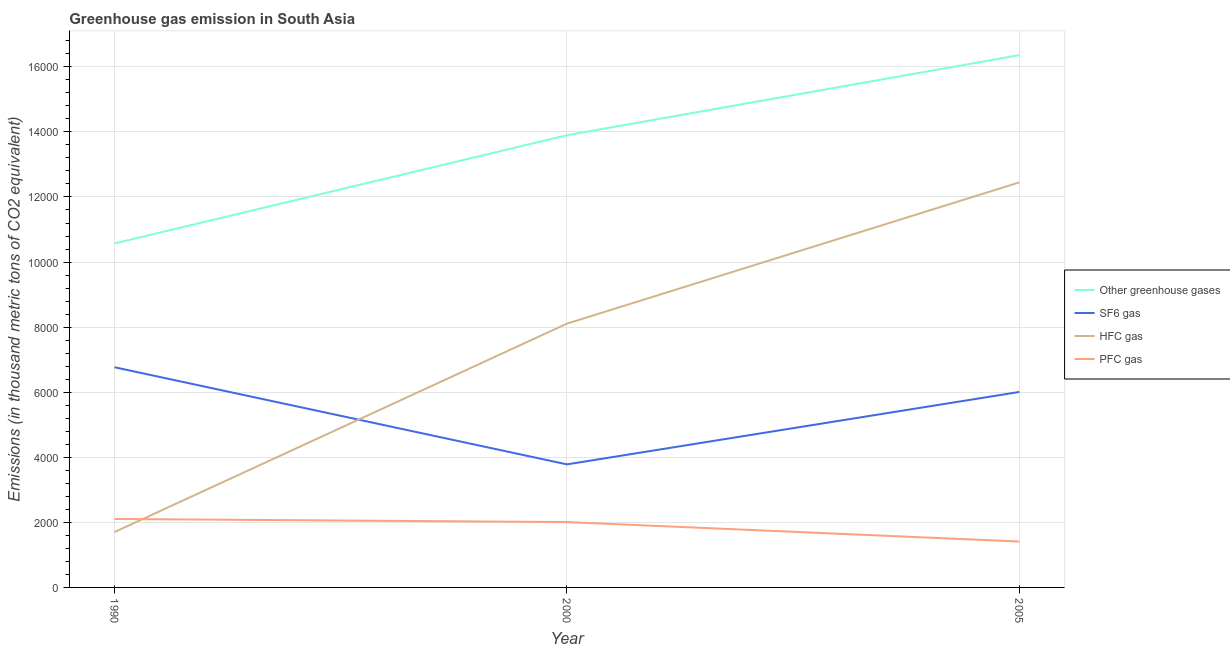How many different coloured lines are there?
Provide a succinct answer. 4. Is the number of lines equal to the number of legend labels?
Provide a succinct answer. Yes. What is the emission of hfc gas in 2005?
Give a very brief answer. 1.24e+04. Across all years, what is the maximum emission of hfc gas?
Offer a very short reply. 1.24e+04. Across all years, what is the minimum emission of hfc gas?
Your answer should be very brief. 1702.1. In which year was the emission of hfc gas minimum?
Make the answer very short. 1990. What is the total emission of greenhouse gases in the graph?
Give a very brief answer. 4.08e+04. What is the difference between the emission of pfc gas in 1990 and that in 2005?
Your answer should be very brief. 693.16. What is the difference between the emission of sf6 gas in 2000 and the emission of greenhouse gases in 2005?
Give a very brief answer. -1.26e+04. What is the average emission of sf6 gas per year?
Your answer should be compact. 5518.65. In the year 2005, what is the difference between the emission of greenhouse gases and emission of hfc gas?
Keep it short and to the point. 3910.64. In how many years, is the emission of sf6 gas greater than 5600 thousand metric tons?
Keep it short and to the point. 2. What is the ratio of the emission of hfc gas in 1990 to that in 2005?
Your answer should be very brief. 0.14. Is the difference between the emission of pfc gas in 2000 and 2005 greater than the difference between the emission of sf6 gas in 2000 and 2005?
Your response must be concise. Yes. What is the difference between the highest and the second highest emission of hfc gas?
Provide a succinct answer. 4341.26. What is the difference between the highest and the lowest emission of greenhouse gases?
Ensure brevity in your answer.  5786.5. In how many years, is the emission of hfc gas greater than the average emission of hfc gas taken over all years?
Your answer should be compact. 2. Is it the case that in every year, the sum of the emission of hfc gas and emission of sf6 gas is greater than the sum of emission of greenhouse gases and emission of pfc gas?
Your answer should be compact. No. Is it the case that in every year, the sum of the emission of greenhouse gases and emission of sf6 gas is greater than the emission of hfc gas?
Your answer should be very brief. Yes. Is the emission of hfc gas strictly greater than the emission of pfc gas over the years?
Make the answer very short. No. How many lines are there?
Keep it short and to the point. 4. Are the values on the major ticks of Y-axis written in scientific E-notation?
Give a very brief answer. No. Does the graph contain any zero values?
Make the answer very short. No. Does the graph contain grids?
Your answer should be compact. Yes. What is the title of the graph?
Make the answer very short. Greenhouse gas emission in South Asia. What is the label or title of the Y-axis?
Offer a very short reply. Emissions (in thousand metric tons of CO2 equivalent). What is the Emissions (in thousand metric tons of CO2 equivalent) in Other greenhouse gases in 1990?
Provide a succinct answer. 1.06e+04. What is the Emissions (in thousand metric tons of CO2 equivalent) of SF6 gas in 1990?
Your answer should be very brief. 6766.5. What is the Emissions (in thousand metric tons of CO2 equivalent) in HFC gas in 1990?
Your answer should be compact. 1702.1. What is the Emissions (in thousand metric tons of CO2 equivalent) in PFC gas in 1990?
Make the answer very short. 2104. What is the Emissions (in thousand metric tons of CO2 equivalent) in Other greenhouse gases in 2000?
Provide a short and direct response. 1.39e+04. What is the Emissions (in thousand metric tons of CO2 equivalent) in SF6 gas in 2000?
Give a very brief answer. 3781.9. What is the Emissions (in thousand metric tons of CO2 equivalent) in HFC gas in 2000?
Make the answer very short. 8107.2. What is the Emissions (in thousand metric tons of CO2 equivalent) of PFC gas in 2000?
Offer a very short reply. 2008.8. What is the Emissions (in thousand metric tons of CO2 equivalent) of Other greenhouse gases in 2005?
Keep it short and to the point. 1.64e+04. What is the Emissions (in thousand metric tons of CO2 equivalent) in SF6 gas in 2005?
Provide a succinct answer. 6007.56. What is the Emissions (in thousand metric tons of CO2 equivalent) in HFC gas in 2005?
Make the answer very short. 1.24e+04. What is the Emissions (in thousand metric tons of CO2 equivalent) of PFC gas in 2005?
Keep it short and to the point. 1410.84. Across all years, what is the maximum Emissions (in thousand metric tons of CO2 equivalent) in Other greenhouse gases?
Give a very brief answer. 1.64e+04. Across all years, what is the maximum Emissions (in thousand metric tons of CO2 equivalent) of SF6 gas?
Provide a succinct answer. 6766.5. Across all years, what is the maximum Emissions (in thousand metric tons of CO2 equivalent) of HFC gas?
Offer a terse response. 1.24e+04. Across all years, what is the maximum Emissions (in thousand metric tons of CO2 equivalent) of PFC gas?
Offer a terse response. 2104. Across all years, what is the minimum Emissions (in thousand metric tons of CO2 equivalent) in Other greenhouse gases?
Give a very brief answer. 1.06e+04. Across all years, what is the minimum Emissions (in thousand metric tons of CO2 equivalent) of SF6 gas?
Your answer should be very brief. 3781.9. Across all years, what is the minimum Emissions (in thousand metric tons of CO2 equivalent) of HFC gas?
Provide a succinct answer. 1702.1. Across all years, what is the minimum Emissions (in thousand metric tons of CO2 equivalent) in PFC gas?
Your answer should be very brief. 1410.84. What is the total Emissions (in thousand metric tons of CO2 equivalent) in Other greenhouse gases in the graph?
Give a very brief answer. 4.08e+04. What is the total Emissions (in thousand metric tons of CO2 equivalent) in SF6 gas in the graph?
Ensure brevity in your answer.  1.66e+04. What is the total Emissions (in thousand metric tons of CO2 equivalent) in HFC gas in the graph?
Provide a succinct answer. 2.23e+04. What is the total Emissions (in thousand metric tons of CO2 equivalent) of PFC gas in the graph?
Offer a very short reply. 5523.64. What is the difference between the Emissions (in thousand metric tons of CO2 equivalent) of Other greenhouse gases in 1990 and that in 2000?
Provide a short and direct response. -3325.3. What is the difference between the Emissions (in thousand metric tons of CO2 equivalent) in SF6 gas in 1990 and that in 2000?
Keep it short and to the point. 2984.6. What is the difference between the Emissions (in thousand metric tons of CO2 equivalent) of HFC gas in 1990 and that in 2000?
Your response must be concise. -6405.1. What is the difference between the Emissions (in thousand metric tons of CO2 equivalent) in PFC gas in 1990 and that in 2000?
Your answer should be very brief. 95.2. What is the difference between the Emissions (in thousand metric tons of CO2 equivalent) in Other greenhouse gases in 1990 and that in 2005?
Provide a succinct answer. -5786.5. What is the difference between the Emissions (in thousand metric tons of CO2 equivalent) in SF6 gas in 1990 and that in 2005?
Provide a short and direct response. 758.94. What is the difference between the Emissions (in thousand metric tons of CO2 equivalent) of HFC gas in 1990 and that in 2005?
Your response must be concise. -1.07e+04. What is the difference between the Emissions (in thousand metric tons of CO2 equivalent) of PFC gas in 1990 and that in 2005?
Give a very brief answer. 693.16. What is the difference between the Emissions (in thousand metric tons of CO2 equivalent) of Other greenhouse gases in 2000 and that in 2005?
Provide a succinct answer. -2461.2. What is the difference between the Emissions (in thousand metric tons of CO2 equivalent) of SF6 gas in 2000 and that in 2005?
Provide a short and direct response. -2225.66. What is the difference between the Emissions (in thousand metric tons of CO2 equivalent) in HFC gas in 2000 and that in 2005?
Give a very brief answer. -4341.26. What is the difference between the Emissions (in thousand metric tons of CO2 equivalent) in PFC gas in 2000 and that in 2005?
Your response must be concise. 597.96. What is the difference between the Emissions (in thousand metric tons of CO2 equivalent) in Other greenhouse gases in 1990 and the Emissions (in thousand metric tons of CO2 equivalent) in SF6 gas in 2000?
Keep it short and to the point. 6790.7. What is the difference between the Emissions (in thousand metric tons of CO2 equivalent) of Other greenhouse gases in 1990 and the Emissions (in thousand metric tons of CO2 equivalent) of HFC gas in 2000?
Provide a short and direct response. 2465.4. What is the difference between the Emissions (in thousand metric tons of CO2 equivalent) of Other greenhouse gases in 1990 and the Emissions (in thousand metric tons of CO2 equivalent) of PFC gas in 2000?
Your answer should be compact. 8563.8. What is the difference between the Emissions (in thousand metric tons of CO2 equivalent) of SF6 gas in 1990 and the Emissions (in thousand metric tons of CO2 equivalent) of HFC gas in 2000?
Provide a short and direct response. -1340.7. What is the difference between the Emissions (in thousand metric tons of CO2 equivalent) in SF6 gas in 1990 and the Emissions (in thousand metric tons of CO2 equivalent) in PFC gas in 2000?
Provide a short and direct response. 4757.7. What is the difference between the Emissions (in thousand metric tons of CO2 equivalent) of HFC gas in 1990 and the Emissions (in thousand metric tons of CO2 equivalent) of PFC gas in 2000?
Your answer should be very brief. -306.7. What is the difference between the Emissions (in thousand metric tons of CO2 equivalent) in Other greenhouse gases in 1990 and the Emissions (in thousand metric tons of CO2 equivalent) in SF6 gas in 2005?
Offer a very short reply. 4565.04. What is the difference between the Emissions (in thousand metric tons of CO2 equivalent) in Other greenhouse gases in 1990 and the Emissions (in thousand metric tons of CO2 equivalent) in HFC gas in 2005?
Ensure brevity in your answer.  -1875.86. What is the difference between the Emissions (in thousand metric tons of CO2 equivalent) of Other greenhouse gases in 1990 and the Emissions (in thousand metric tons of CO2 equivalent) of PFC gas in 2005?
Ensure brevity in your answer.  9161.76. What is the difference between the Emissions (in thousand metric tons of CO2 equivalent) in SF6 gas in 1990 and the Emissions (in thousand metric tons of CO2 equivalent) in HFC gas in 2005?
Keep it short and to the point. -5681.96. What is the difference between the Emissions (in thousand metric tons of CO2 equivalent) of SF6 gas in 1990 and the Emissions (in thousand metric tons of CO2 equivalent) of PFC gas in 2005?
Give a very brief answer. 5355.66. What is the difference between the Emissions (in thousand metric tons of CO2 equivalent) of HFC gas in 1990 and the Emissions (in thousand metric tons of CO2 equivalent) of PFC gas in 2005?
Provide a short and direct response. 291.26. What is the difference between the Emissions (in thousand metric tons of CO2 equivalent) of Other greenhouse gases in 2000 and the Emissions (in thousand metric tons of CO2 equivalent) of SF6 gas in 2005?
Provide a succinct answer. 7890.34. What is the difference between the Emissions (in thousand metric tons of CO2 equivalent) in Other greenhouse gases in 2000 and the Emissions (in thousand metric tons of CO2 equivalent) in HFC gas in 2005?
Your answer should be compact. 1449.44. What is the difference between the Emissions (in thousand metric tons of CO2 equivalent) of Other greenhouse gases in 2000 and the Emissions (in thousand metric tons of CO2 equivalent) of PFC gas in 2005?
Your response must be concise. 1.25e+04. What is the difference between the Emissions (in thousand metric tons of CO2 equivalent) of SF6 gas in 2000 and the Emissions (in thousand metric tons of CO2 equivalent) of HFC gas in 2005?
Give a very brief answer. -8666.56. What is the difference between the Emissions (in thousand metric tons of CO2 equivalent) of SF6 gas in 2000 and the Emissions (in thousand metric tons of CO2 equivalent) of PFC gas in 2005?
Provide a succinct answer. 2371.06. What is the difference between the Emissions (in thousand metric tons of CO2 equivalent) in HFC gas in 2000 and the Emissions (in thousand metric tons of CO2 equivalent) in PFC gas in 2005?
Provide a succinct answer. 6696.36. What is the average Emissions (in thousand metric tons of CO2 equivalent) in Other greenhouse gases per year?
Your response must be concise. 1.36e+04. What is the average Emissions (in thousand metric tons of CO2 equivalent) of SF6 gas per year?
Offer a terse response. 5518.65. What is the average Emissions (in thousand metric tons of CO2 equivalent) in HFC gas per year?
Your response must be concise. 7419.25. What is the average Emissions (in thousand metric tons of CO2 equivalent) in PFC gas per year?
Your response must be concise. 1841.21. In the year 1990, what is the difference between the Emissions (in thousand metric tons of CO2 equivalent) in Other greenhouse gases and Emissions (in thousand metric tons of CO2 equivalent) in SF6 gas?
Your answer should be very brief. 3806.1. In the year 1990, what is the difference between the Emissions (in thousand metric tons of CO2 equivalent) of Other greenhouse gases and Emissions (in thousand metric tons of CO2 equivalent) of HFC gas?
Ensure brevity in your answer.  8870.5. In the year 1990, what is the difference between the Emissions (in thousand metric tons of CO2 equivalent) in Other greenhouse gases and Emissions (in thousand metric tons of CO2 equivalent) in PFC gas?
Your response must be concise. 8468.6. In the year 1990, what is the difference between the Emissions (in thousand metric tons of CO2 equivalent) in SF6 gas and Emissions (in thousand metric tons of CO2 equivalent) in HFC gas?
Your answer should be very brief. 5064.4. In the year 1990, what is the difference between the Emissions (in thousand metric tons of CO2 equivalent) in SF6 gas and Emissions (in thousand metric tons of CO2 equivalent) in PFC gas?
Provide a succinct answer. 4662.5. In the year 1990, what is the difference between the Emissions (in thousand metric tons of CO2 equivalent) of HFC gas and Emissions (in thousand metric tons of CO2 equivalent) of PFC gas?
Offer a terse response. -401.9. In the year 2000, what is the difference between the Emissions (in thousand metric tons of CO2 equivalent) in Other greenhouse gases and Emissions (in thousand metric tons of CO2 equivalent) in SF6 gas?
Make the answer very short. 1.01e+04. In the year 2000, what is the difference between the Emissions (in thousand metric tons of CO2 equivalent) of Other greenhouse gases and Emissions (in thousand metric tons of CO2 equivalent) of HFC gas?
Make the answer very short. 5790.7. In the year 2000, what is the difference between the Emissions (in thousand metric tons of CO2 equivalent) of Other greenhouse gases and Emissions (in thousand metric tons of CO2 equivalent) of PFC gas?
Give a very brief answer. 1.19e+04. In the year 2000, what is the difference between the Emissions (in thousand metric tons of CO2 equivalent) in SF6 gas and Emissions (in thousand metric tons of CO2 equivalent) in HFC gas?
Your answer should be compact. -4325.3. In the year 2000, what is the difference between the Emissions (in thousand metric tons of CO2 equivalent) in SF6 gas and Emissions (in thousand metric tons of CO2 equivalent) in PFC gas?
Ensure brevity in your answer.  1773.1. In the year 2000, what is the difference between the Emissions (in thousand metric tons of CO2 equivalent) of HFC gas and Emissions (in thousand metric tons of CO2 equivalent) of PFC gas?
Your answer should be very brief. 6098.4. In the year 2005, what is the difference between the Emissions (in thousand metric tons of CO2 equivalent) of Other greenhouse gases and Emissions (in thousand metric tons of CO2 equivalent) of SF6 gas?
Your answer should be compact. 1.04e+04. In the year 2005, what is the difference between the Emissions (in thousand metric tons of CO2 equivalent) in Other greenhouse gases and Emissions (in thousand metric tons of CO2 equivalent) in HFC gas?
Your answer should be compact. 3910.64. In the year 2005, what is the difference between the Emissions (in thousand metric tons of CO2 equivalent) in Other greenhouse gases and Emissions (in thousand metric tons of CO2 equivalent) in PFC gas?
Your answer should be compact. 1.49e+04. In the year 2005, what is the difference between the Emissions (in thousand metric tons of CO2 equivalent) of SF6 gas and Emissions (in thousand metric tons of CO2 equivalent) of HFC gas?
Provide a short and direct response. -6440.9. In the year 2005, what is the difference between the Emissions (in thousand metric tons of CO2 equivalent) of SF6 gas and Emissions (in thousand metric tons of CO2 equivalent) of PFC gas?
Your answer should be very brief. 4596.72. In the year 2005, what is the difference between the Emissions (in thousand metric tons of CO2 equivalent) in HFC gas and Emissions (in thousand metric tons of CO2 equivalent) in PFC gas?
Your answer should be very brief. 1.10e+04. What is the ratio of the Emissions (in thousand metric tons of CO2 equivalent) of Other greenhouse gases in 1990 to that in 2000?
Offer a very short reply. 0.76. What is the ratio of the Emissions (in thousand metric tons of CO2 equivalent) of SF6 gas in 1990 to that in 2000?
Give a very brief answer. 1.79. What is the ratio of the Emissions (in thousand metric tons of CO2 equivalent) of HFC gas in 1990 to that in 2000?
Offer a very short reply. 0.21. What is the ratio of the Emissions (in thousand metric tons of CO2 equivalent) of PFC gas in 1990 to that in 2000?
Offer a terse response. 1.05. What is the ratio of the Emissions (in thousand metric tons of CO2 equivalent) of Other greenhouse gases in 1990 to that in 2005?
Keep it short and to the point. 0.65. What is the ratio of the Emissions (in thousand metric tons of CO2 equivalent) of SF6 gas in 1990 to that in 2005?
Your answer should be compact. 1.13. What is the ratio of the Emissions (in thousand metric tons of CO2 equivalent) of HFC gas in 1990 to that in 2005?
Ensure brevity in your answer.  0.14. What is the ratio of the Emissions (in thousand metric tons of CO2 equivalent) of PFC gas in 1990 to that in 2005?
Your answer should be compact. 1.49. What is the ratio of the Emissions (in thousand metric tons of CO2 equivalent) of Other greenhouse gases in 2000 to that in 2005?
Provide a succinct answer. 0.85. What is the ratio of the Emissions (in thousand metric tons of CO2 equivalent) in SF6 gas in 2000 to that in 2005?
Your answer should be compact. 0.63. What is the ratio of the Emissions (in thousand metric tons of CO2 equivalent) in HFC gas in 2000 to that in 2005?
Give a very brief answer. 0.65. What is the ratio of the Emissions (in thousand metric tons of CO2 equivalent) in PFC gas in 2000 to that in 2005?
Your answer should be very brief. 1.42. What is the difference between the highest and the second highest Emissions (in thousand metric tons of CO2 equivalent) in Other greenhouse gases?
Offer a terse response. 2461.2. What is the difference between the highest and the second highest Emissions (in thousand metric tons of CO2 equivalent) of SF6 gas?
Offer a very short reply. 758.94. What is the difference between the highest and the second highest Emissions (in thousand metric tons of CO2 equivalent) in HFC gas?
Provide a succinct answer. 4341.26. What is the difference between the highest and the second highest Emissions (in thousand metric tons of CO2 equivalent) in PFC gas?
Provide a succinct answer. 95.2. What is the difference between the highest and the lowest Emissions (in thousand metric tons of CO2 equivalent) of Other greenhouse gases?
Your answer should be compact. 5786.5. What is the difference between the highest and the lowest Emissions (in thousand metric tons of CO2 equivalent) in SF6 gas?
Provide a succinct answer. 2984.6. What is the difference between the highest and the lowest Emissions (in thousand metric tons of CO2 equivalent) of HFC gas?
Your answer should be very brief. 1.07e+04. What is the difference between the highest and the lowest Emissions (in thousand metric tons of CO2 equivalent) in PFC gas?
Your answer should be compact. 693.16. 